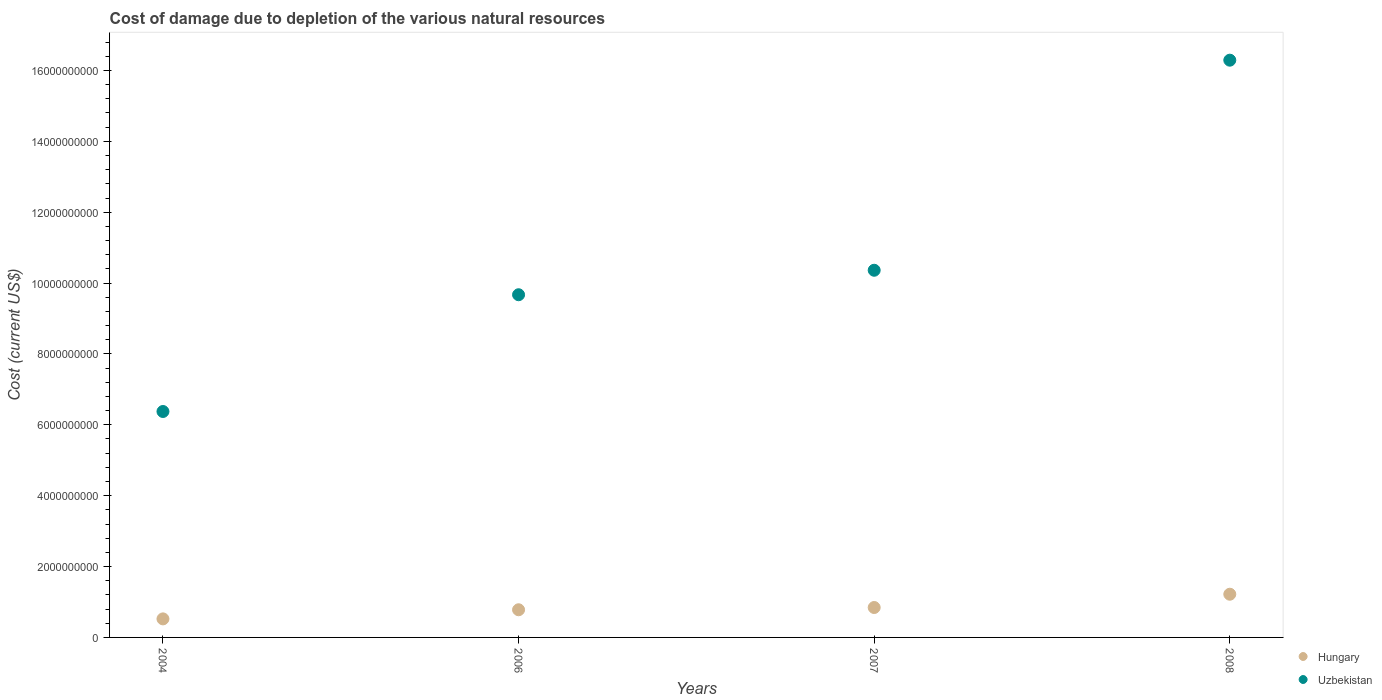Is the number of dotlines equal to the number of legend labels?
Your answer should be compact. Yes. What is the cost of damage caused due to the depletion of various natural resources in Hungary in 2008?
Make the answer very short. 1.22e+09. Across all years, what is the maximum cost of damage caused due to the depletion of various natural resources in Hungary?
Make the answer very short. 1.22e+09. Across all years, what is the minimum cost of damage caused due to the depletion of various natural resources in Hungary?
Ensure brevity in your answer.  5.23e+08. What is the total cost of damage caused due to the depletion of various natural resources in Hungary in the graph?
Make the answer very short. 3.37e+09. What is the difference between the cost of damage caused due to the depletion of various natural resources in Hungary in 2007 and that in 2008?
Offer a terse response. -3.75e+08. What is the difference between the cost of damage caused due to the depletion of various natural resources in Uzbekistan in 2008 and the cost of damage caused due to the depletion of various natural resources in Hungary in 2007?
Your answer should be very brief. 1.54e+1. What is the average cost of damage caused due to the depletion of various natural resources in Hungary per year?
Give a very brief answer. 8.42e+08. In the year 2008, what is the difference between the cost of damage caused due to the depletion of various natural resources in Hungary and cost of damage caused due to the depletion of various natural resources in Uzbekistan?
Make the answer very short. -1.51e+1. In how many years, is the cost of damage caused due to the depletion of various natural resources in Uzbekistan greater than 12800000000 US$?
Your response must be concise. 1. What is the ratio of the cost of damage caused due to the depletion of various natural resources in Hungary in 2006 to that in 2007?
Your answer should be very brief. 0.92. Is the cost of damage caused due to the depletion of various natural resources in Uzbekistan in 2006 less than that in 2008?
Keep it short and to the point. Yes. Is the difference between the cost of damage caused due to the depletion of various natural resources in Hungary in 2004 and 2006 greater than the difference between the cost of damage caused due to the depletion of various natural resources in Uzbekistan in 2004 and 2006?
Provide a succinct answer. Yes. What is the difference between the highest and the second highest cost of damage caused due to the depletion of various natural resources in Uzbekistan?
Provide a short and direct response. 5.93e+09. What is the difference between the highest and the lowest cost of damage caused due to the depletion of various natural resources in Hungary?
Your answer should be very brief. 6.96e+08. In how many years, is the cost of damage caused due to the depletion of various natural resources in Uzbekistan greater than the average cost of damage caused due to the depletion of various natural resources in Uzbekistan taken over all years?
Your response must be concise. 1. Is the sum of the cost of damage caused due to the depletion of various natural resources in Uzbekistan in 2004 and 2006 greater than the maximum cost of damage caused due to the depletion of various natural resources in Hungary across all years?
Your answer should be compact. Yes. Is the cost of damage caused due to the depletion of various natural resources in Uzbekistan strictly less than the cost of damage caused due to the depletion of various natural resources in Hungary over the years?
Keep it short and to the point. No. How many dotlines are there?
Your response must be concise. 2. How many years are there in the graph?
Your response must be concise. 4. Does the graph contain any zero values?
Make the answer very short. No. Where does the legend appear in the graph?
Your answer should be very brief. Bottom right. What is the title of the graph?
Your response must be concise. Cost of damage due to depletion of the various natural resources. What is the label or title of the X-axis?
Offer a terse response. Years. What is the label or title of the Y-axis?
Your response must be concise. Cost (current US$). What is the Cost (current US$) of Hungary in 2004?
Give a very brief answer. 5.23e+08. What is the Cost (current US$) of Uzbekistan in 2004?
Your answer should be compact. 6.38e+09. What is the Cost (current US$) in Hungary in 2006?
Ensure brevity in your answer.  7.81e+08. What is the Cost (current US$) in Uzbekistan in 2006?
Offer a terse response. 9.67e+09. What is the Cost (current US$) of Hungary in 2007?
Keep it short and to the point. 8.44e+08. What is the Cost (current US$) in Uzbekistan in 2007?
Ensure brevity in your answer.  1.04e+1. What is the Cost (current US$) of Hungary in 2008?
Keep it short and to the point. 1.22e+09. What is the Cost (current US$) of Uzbekistan in 2008?
Ensure brevity in your answer.  1.63e+1. Across all years, what is the maximum Cost (current US$) in Hungary?
Give a very brief answer. 1.22e+09. Across all years, what is the maximum Cost (current US$) in Uzbekistan?
Ensure brevity in your answer.  1.63e+1. Across all years, what is the minimum Cost (current US$) of Hungary?
Keep it short and to the point. 5.23e+08. Across all years, what is the minimum Cost (current US$) in Uzbekistan?
Provide a succinct answer. 6.38e+09. What is the total Cost (current US$) in Hungary in the graph?
Give a very brief answer. 3.37e+09. What is the total Cost (current US$) in Uzbekistan in the graph?
Provide a short and direct response. 4.27e+1. What is the difference between the Cost (current US$) of Hungary in 2004 and that in 2006?
Provide a succinct answer. -2.57e+08. What is the difference between the Cost (current US$) in Uzbekistan in 2004 and that in 2006?
Your answer should be very brief. -3.29e+09. What is the difference between the Cost (current US$) of Hungary in 2004 and that in 2007?
Offer a terse response. -3.21e+08. What is the difference between the Cost (current US$) of Uzbekistan in 2004 and that in 2007?
Offer a very short reply. -3.99e+09. What is the difference between the Cost (current US$) in Hungary in 2004 and that in 2008?
Make the answer very short. -6.96e+08. What is the difference between the Cost (current US$) of Uzbekistan in 2004 and that in 2008?
Ensure brevity in your answer.  -9.91e+09. What is the difference between the Cost (current US$) of Hungary in 2006 and that in 2007?
Your answer should be very brief. -6.36e+07. What is the difference between the Cost (current US$) in Uzbekistan in 2006 and that in 2007?
Your response must be concise. -6.91e+08. What is the difference between the Cost (current US$) of Hungary in 2006 and that in 2008?
Your response must be concise. -4.38e+08. What is the difference between the Cost (current US$) in Uzbekistan in 2006 and that in 2008?
Offer a very short reply. -6.62e+09. What is the difference between the Cost (current US$) in Hungary in 2007 and that in 2008?
Make the answer very short. -3.75e+08. What is the difference between the Cost (current US$) of Uzbekistan in 2007 and that in 2008?
Your answer should be compact. -5.93e+09. What is the difference between the Cost (current US$) of Hungary in 2004 and the Cost (current US$) of Uzbekistan in 2006?
Offer a terse response. -9.15e+09. What is the difference between the Cost (current US$) in Hungary in 2004 and the Cost (current US$) in Uzbekistan in 2007?
Offer a terse response. -9.84e+09. What is the difference between the Cost (current US$) of Hungary in 2004 and the Cost (current US$) of Uzbekistan in 2008?
Offer a terse response. -1.58e+1. What is the difference between the Cost (current US$) in Hungary in 2006 and the Cost (current US$) in Uzbekistan in 2007?
Give a very brief answer. -9.58e+09. What is the difference between the Cost (current US$) in Hungary in 2006 and the Cost (current US$) in Uzbekistan in 2008?
Give a very brief answer. -1.55e+1. What is the difference between the Cost (current US$) in Hungary in 2007 and the Cost (current US$) in Uzbekistan in 2008?
Your answer should be compact. -1.54e+1. What is the average Cost (current US$) in Hungary per year?
Ensure brevity in your answer.  8.42e+08. What is the average Cost (current US$) in Uzbekistan per year?
Offer a terse response. 1.07e+1. In the year 2004, what is the difference between the Cost (current US$) in Hungary and Cost (current US$) in Uzbekistan?
Provide a short and direct response. -5.85e+09. In the year 2006, what is the difference between the Cost (current US$) in Hungary and Cost (current US$) in Uzbekistan?
Ensure brevity in your answer.  -8.89e+09. In the year 2007, what is the difference between the Cost (current US$) in Hungary and Cost (current US$) in Uzbekistan?
Make the answer very short. -9.52e+09. In the year 2008, what is the difference between the Cost (current US$) of Hungary and Cost (current US$) of Uzbekistan?
Your answer should be very brief. -1.51e+1. What is the ratio of the Cost (current US$) of Hungary in 2004 to that in 2006?
Your answer should be compact. 0.67. What is the ratio of the Cost (current US$) of Uzbekistan in 2004 to that in 2006?
Ensure brevity in your answer.  0.66. What is the ratio of the Cost (current US$) of Hungary in 2004 to that in 2007?
Your response must be concise. 0.62. What is the ratio of the Cost (current US$) in Uzbekistan in 2004 to that in 2007?
Ensure brevity in your answer.  0.62. What is the ratio of the Cost (current US$) of Hungary in 2004 to that in 2008?
Your answer should be very brief. 0.43. What is the ratio of the Cost (current US$) of Uzbekistan in 2004 to that in 2008?
Offer a very short reply. 0.39. What is the ratio of the Cost (current US$) of Hungary in 2006 to that in 2007?
Keep it short and to the point. 0.92. What is the ratio of the Cost (current US$) of Uzbekistan in 2006 to that in 2007?
Provide a short and direct response. 0.93. What is the ratio of the Cost (current US$) of Hungary in 2006 to that in 2008?
Your answer should be compact. 0.64. What is the ratio of the Cost (current US$) in Uzbekistan in 2006 to that in 2008?
Your answer should be compact. 0.59. What is the ratio of the Cost (current US$) in Hungary in 2007 to that in 2008?
Your answer should be compact. 0.69. What is the ratio of the Cost (current US$) in Uzbekistan in 2007 to that in 2008?
Provide a succinct answer. 0.64. What is the difference between the highest and the second highest Cost (current US$) in Hungary?
Keep it short and to the point. 3.75e+08. What is the difference between the highest and the second highest Cost (current US$) in Uzbekistan?
Your answer should be compact. 5.93e+09. What is the difference between the highest and the lowest Cost (current US$) of Hungary?
Provide a short and direct response. 6.96e+08. What is the difference between the highest and the lowest Cost (current US$) in Uzbekistan?
Your response must be concise. 9.91e+09. 